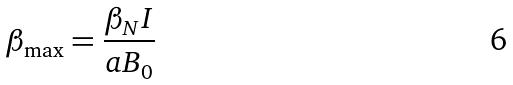Convert formula to latex. <formula><loc_0><loc_0><loc_500><loc_500>\beta _ { \max } = \frac { \beta _ { N } I } { a B _ { 0 } }</formula> 